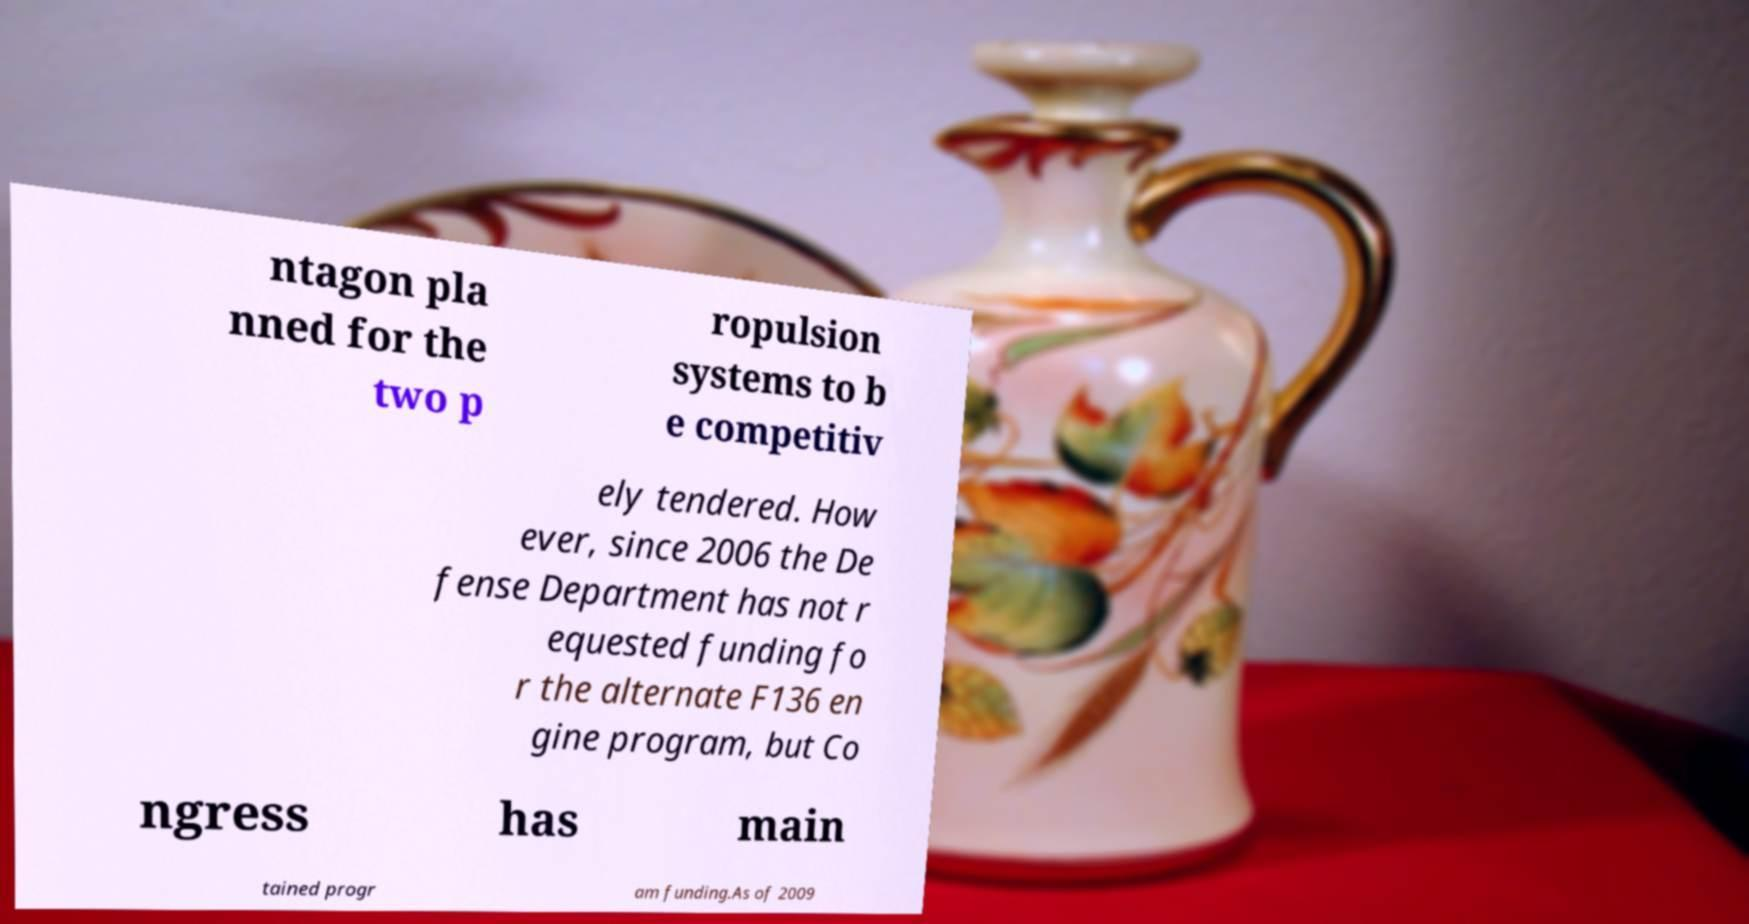Can you read and provide the text displayed in the image?This photo seems to have some interesting text. Can you extract and type it out for me? ntagon pla nned for the two p ropulsion systems to b e competitiv ely tendered. How ever, since 2006 the De fense Department has not r equested funding fo r the alternate F136 en gine program, but Co ngress has main tained progr am funding.As of 2009 